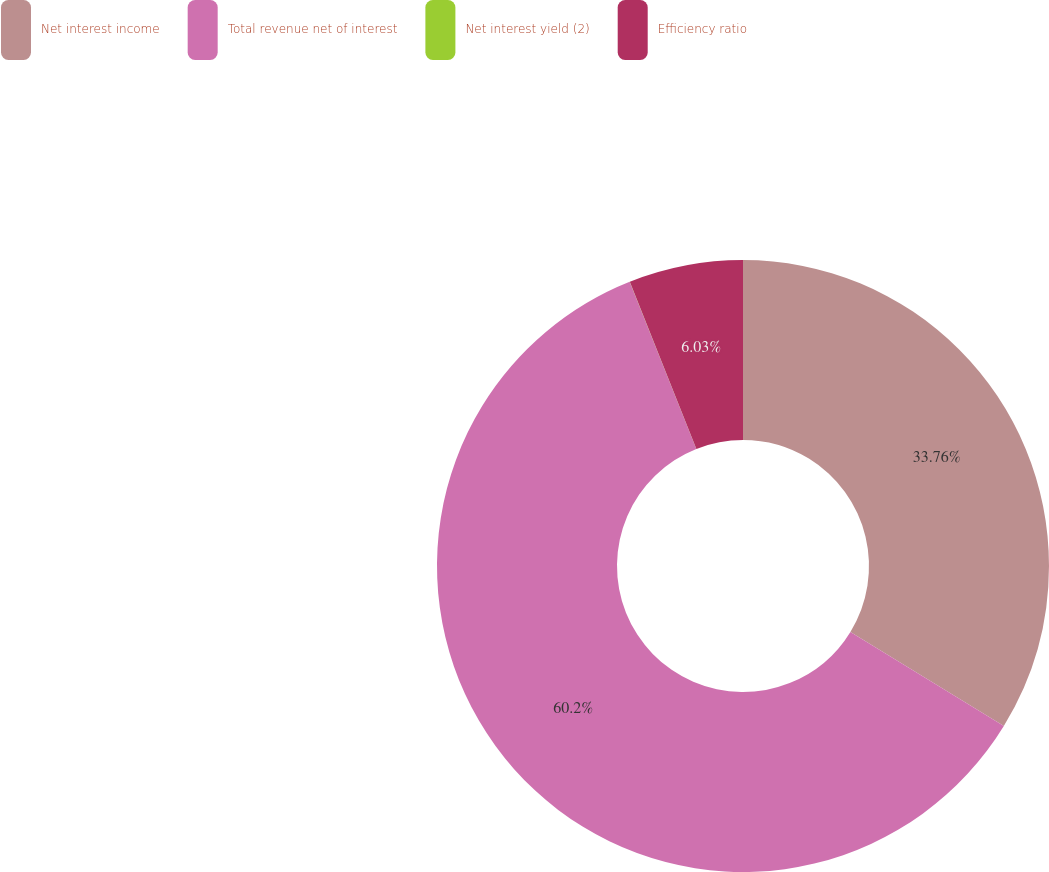Convert chart. <chart><loc_0><loc_0><loc_500><loc_500><pie_chart><fcel>Net interest income<fcel>Total revenue net of interest<fcel>Net interest yield (2)<fcel>Efficiency ratio<nl><fcel>33.76%<fcel>60.21%<fcel>0.01%<fcel>6.03%<nl></chart> 